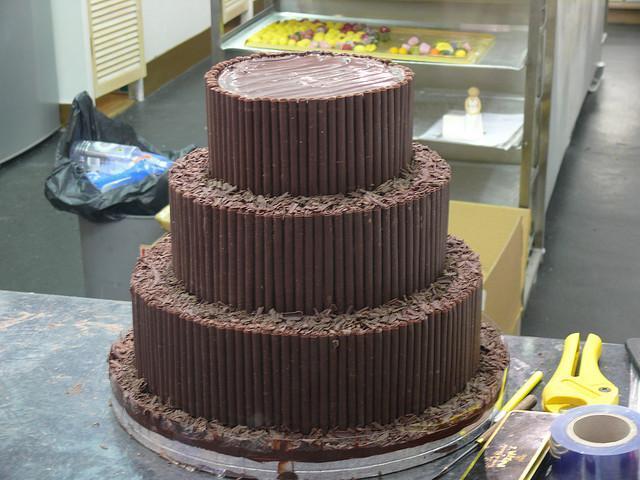How many tiers does this cake have?
Give a very brief answer. 3. How many dining tables are in the picture?
Give a very brief answer. 2. How many people are wearing goggles?
Give a very brief answer. 0. 